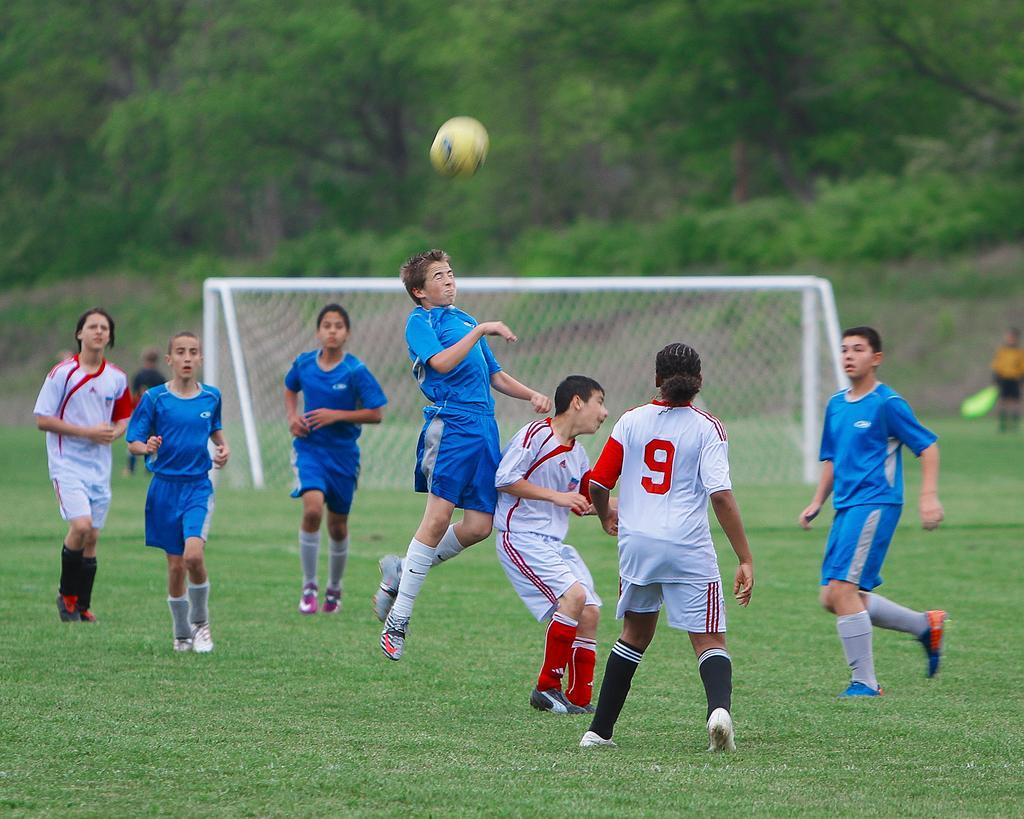How would you summarize this image in a sentence or two? In this image we can see some players in the ground. On the backside we can see a football goal net and some trees. We can also see a ball. 